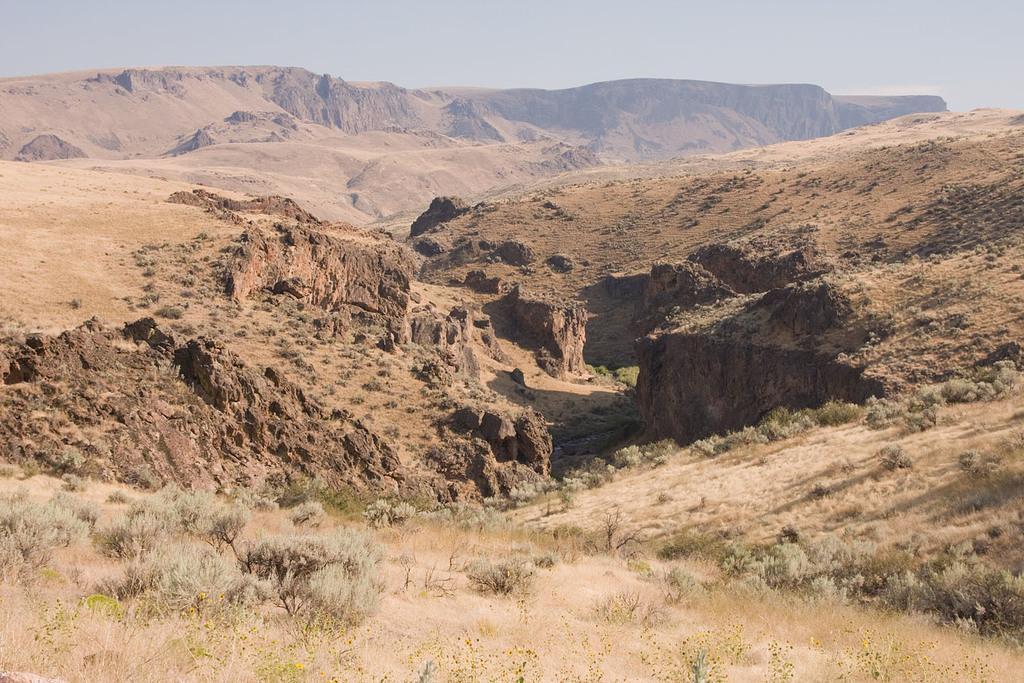How would you summarize this image in a sentence or two? In this image I can see grass, plants, mountains and the sky. This image is taken may be in a desert land. 